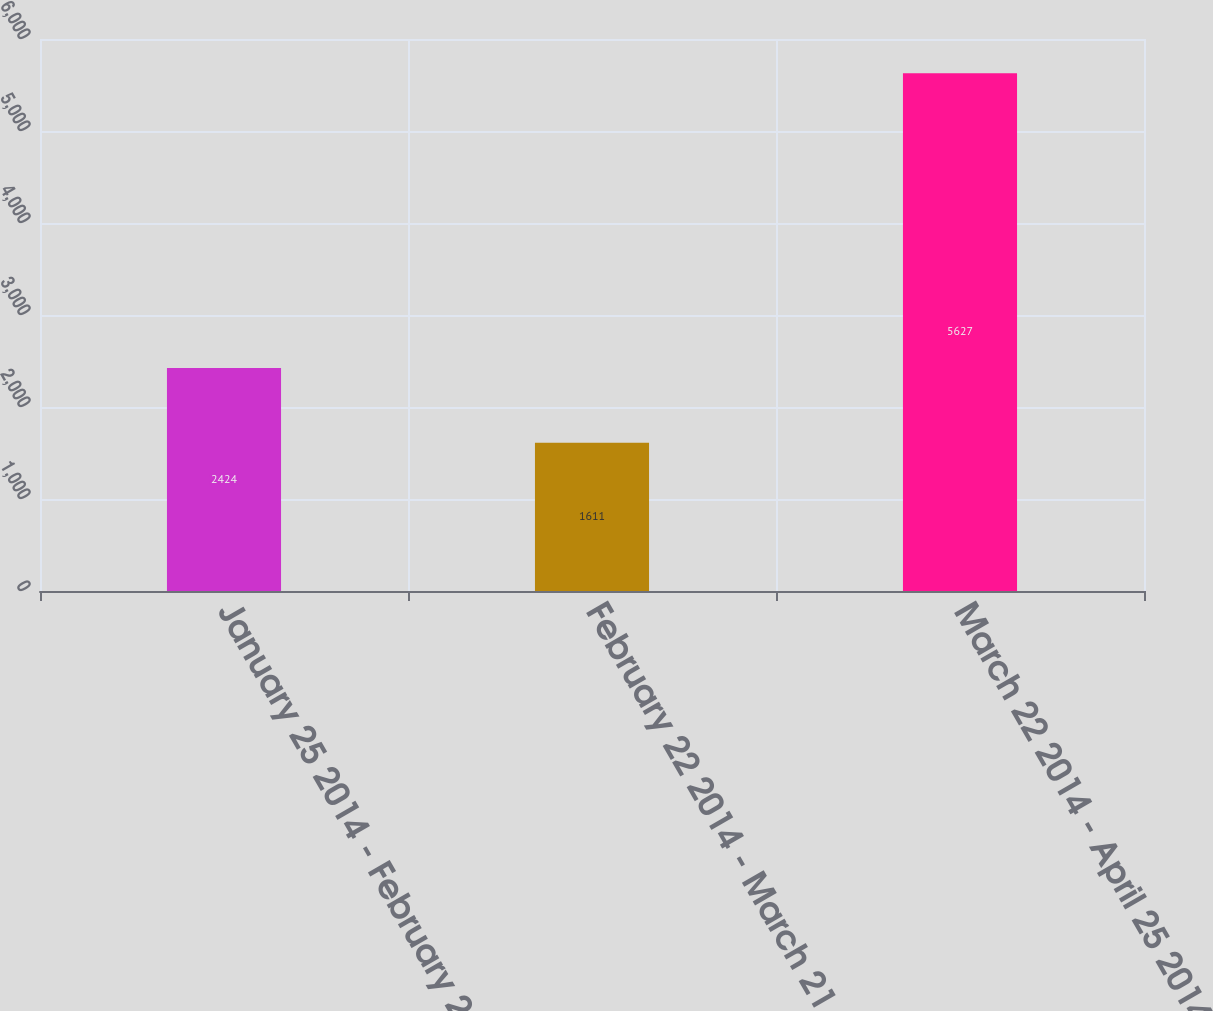Convert chart. <chart><loc_0><loc_0><loc_500><loc_500><bar_chart><fcel>January 25 2014 - February 21<fcel>February 22 2014 - March 21<fcel>March 22 2014 - April 25 2014<nl><fcel>2424<fcel>1611<fcel>5627<nl></chart> 